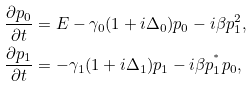Convert formula to latex. <formula><loc_0><loc_0><loc_500><loc_500>\frac { \partial p _ { 0 } } { \partial t } & = E - \gamma _ { 0 } ( 1 + i \Delta _ { 0 } ) p _ { 0 } - i \beta p _ { 1 } ^ { 2 } , \\ \frac { \partial p _ { 1 } } { \partial t } & = - \gamma _ { 1 } ( 1 + i \Delta _ { 1 } ) p _ { 1 } - i \beta p _ { 1 } ^ { ^ { * } } p _ { 0 } ,</formula> 